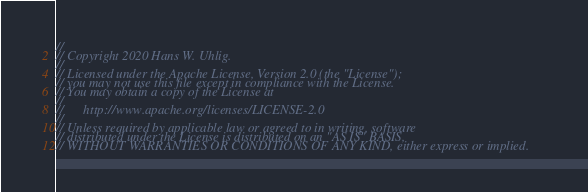<code> <loc_0><loc_0><loc_500><loc_500><_Rust_>//
// Copyright 2020 Hans W. Uhlig.
//
// Licensed under the Apache License, Version 2.0 (the "License");
// you may not use this file except in compliance with the License.
// You may obtain a copy of the License at
//
//      http://www.apache.org/licenses/LICENSE-2.0
//
// Unless required by applicable law or agreed to in writing, software
// distributed under the License is distributed on an "AS IS" BASIS,
// WITHOUT WARRANTIES OR CONDITIONS OF ANY KIND, either express or implied.</code> 